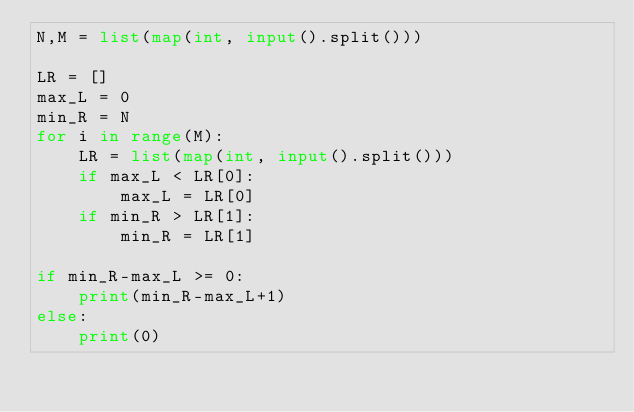<code> <loc_0><loc_0><loc_500><loc_500><_Python_>N,M = list(map(int, input().split()))

LR = []
max_L = 0
min_R = N
for i in range(M):
    LR = list(map(int, input().split()))
    if max_L < LR[0]:
        max_L = LR[0]
    if min_R > LR[1]:
        min_R = LR[1]

if min_R-max_L >= 0:
    print(min_R-max_L+1)
else:
    print(0)</code> 